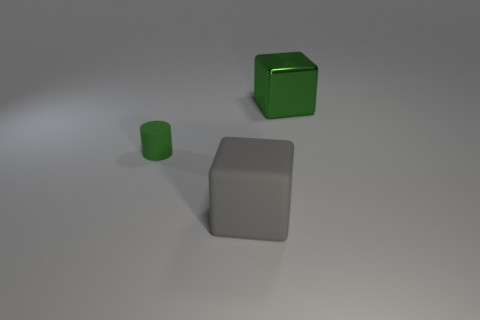Add 1 cubes. How many objects exist? 4 Subtract all cubes. How many objects are left? 1 Subtract all cyan spheres. How many red cubes are left? 0 Subtract 0 cyan spheres. How many objects are left? 3 Subtract all cyan blocks. Subtract all purple cylinders. How many blocks are left? 2 Subtract all large yellow shiny things. Subtract all big cubes. How many objects are left? 1 Add 2 large gray matte cubes. How many large gray matte cubes are left? 3 Add 3 small green rubber cylinders. How many small green rubber cylinders exist? 4 